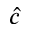<formula> <loc_0><loc_0><loc_500><loc_500>\hat { c }</formula> 